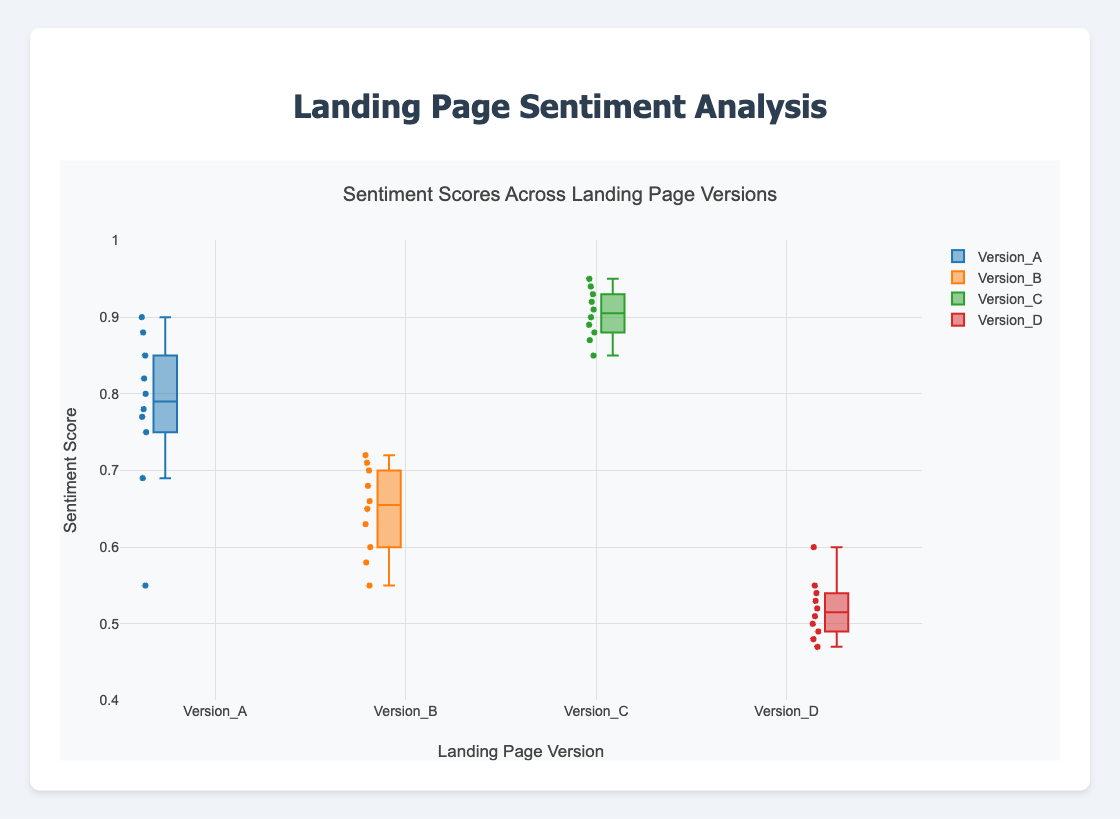How many landing page versions are compared in the figure? By inspecting the x-axis labels or the number of box plots displayed, we can count the distinct landing page versions. There are four versions: Version_A, Version_B, Version_C, and Version_D.
Answer: 4 Which version has the highest median sentiment score? By visually inspecting the median lines (middle line within each box) across the different box plots, Version_C has the highest median sentiment score.
Answer: Version_C What is the range of sentiment scores for Version_D? To find the range, identify the minimum and maximum values represented by the whiskers of the Version_D box plot. The minimum is 0.47 and the maximum is 0.60, so the range is 0.60 - 0.47.
Answer: 0.13 Which version(s) have sentiment scores that go below 0.6? By examining the whiskers and outliers of each box plot, both Version_B and Version_D have sentiment scores below 0.6.
Answer: Version_B and Version_D What is the interquartile range (IQR) for Version_A? The interquartile range (IQR) is found by subtracting the first quartile (Q1) value from the third quartile (Q3) value in the Version_A box plot. The values are roughly Q1=0.76 and Q3=0.85, making the IQR = 0.85 - 0.76.
Answer: 0.09 Which version has the most variability in sentiment scores? The variability is represented by the height of the box (IQR) and the length of the whiskers. Version_A has both a larger IQR and longer whiskers compared to the other versions, indicating the most variability.
Answer: Version_A Are there any outliers in the sentiment scores for Version_C? Outliers are typically indicated by individual points outside the whiskers. Upon inspection, there are no points beyond the whiskers for Version_C, indicating no outliers.
Answer: No Compare the median sentiment scores of Version_A and Version_B. Which is higher? By examining the median lines in the box plots, the median sentiment score of Version_A is higher than that of Version_B.
Answer: Version_A What is the lowest sentiment score recorded across all versions? By scanning the whiskers for the minimum values in all box plots, the lowest sentiment score recorded is in Version_D, which is 0.47.
Answer: 0.47 